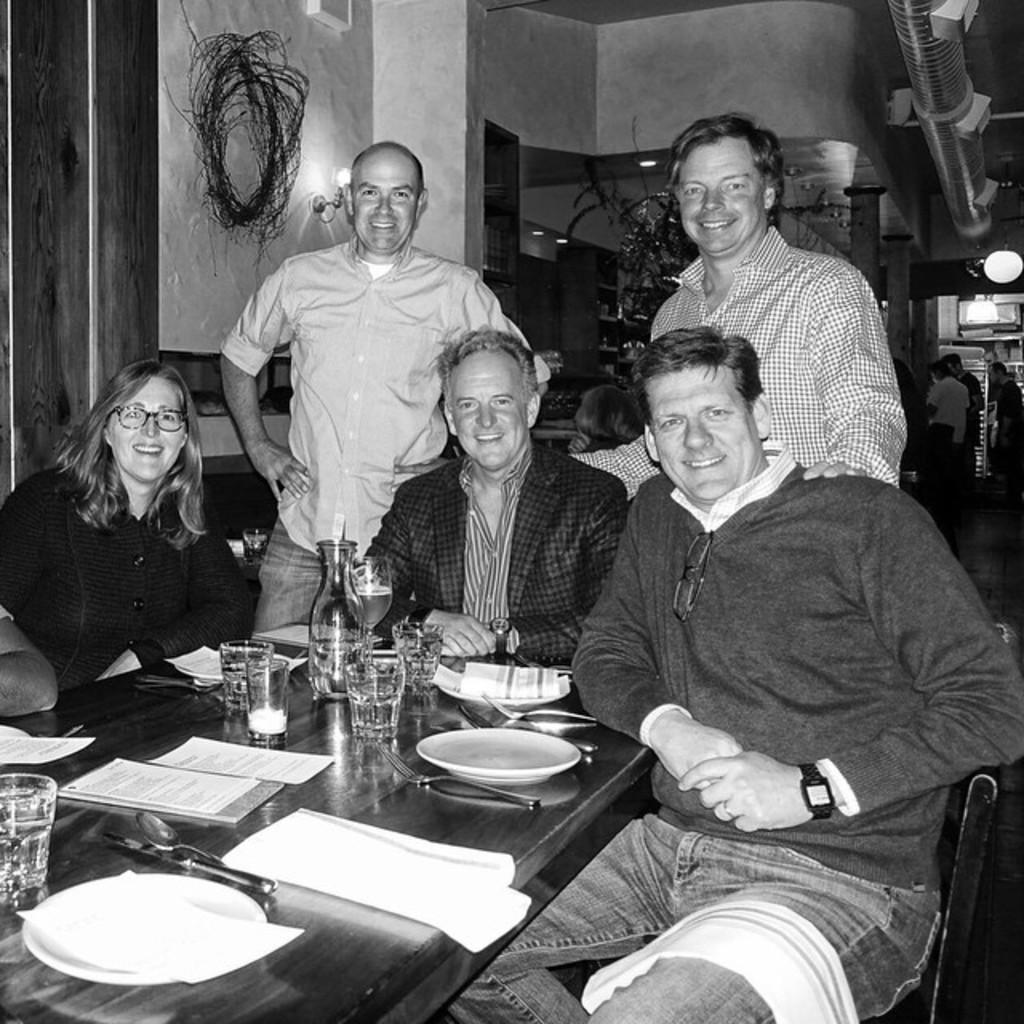Could you give a brief overview of what you see in this image? This picture describes about group of people, few are seated on the chairs and few are standing, in front of them we can find few plates, papers, glasses, bottle and other things on the table, behind them we can find a pipe and few lights. 